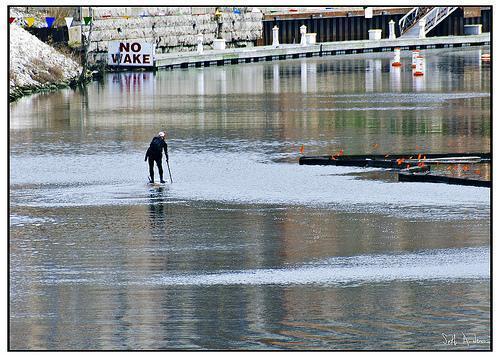How many people are in the photo?
Give a very brief answer. 1. How many people are visible?
Give a very brief answer. 1. How many men are paddling on top of the water?
Give a very brief answer. 1. 